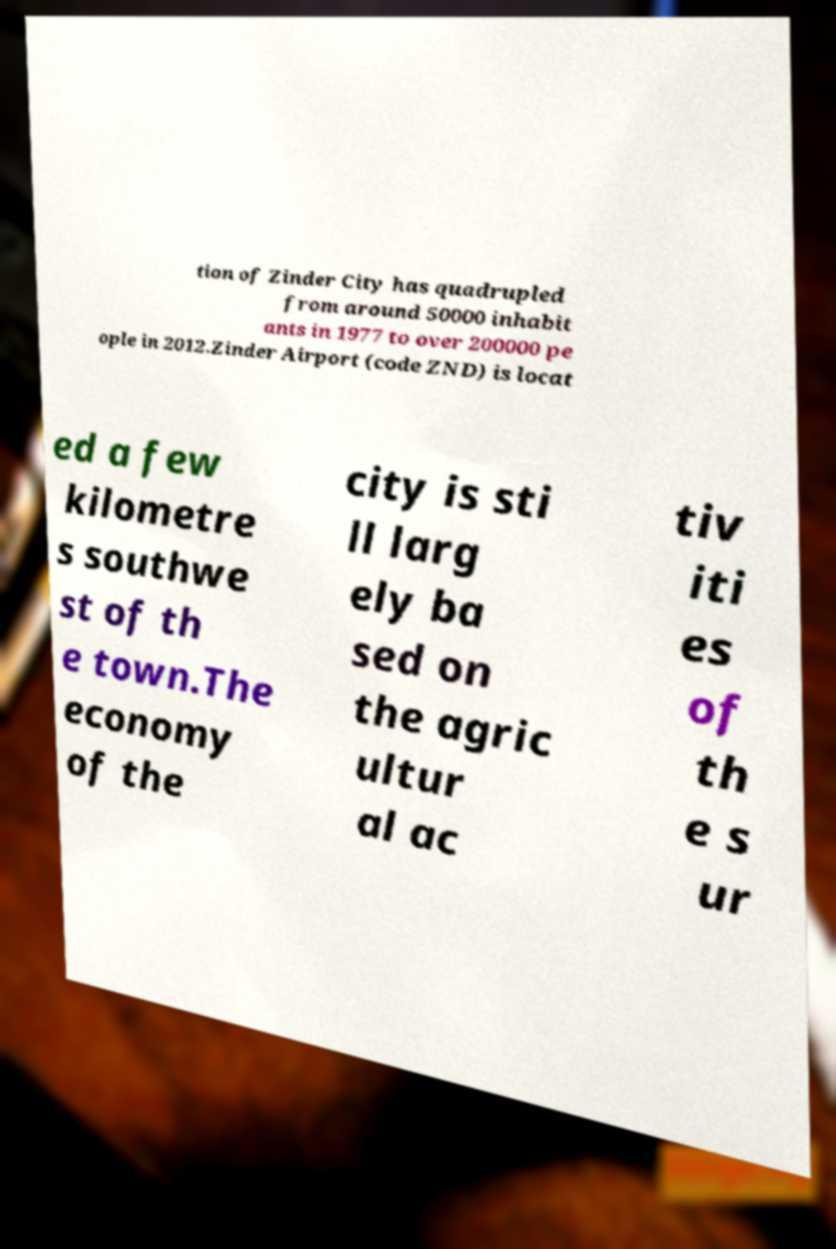I need the written content from this picture converted into text. Can you do that? tion of Zinder City has quadrupled from around 50000 inhabit ants in 1977 to over 200000 pe ople in 2012.Zinder Airport (code ZND) is locat ed a few kilometre s southwe st of th e town.The economy of the city is sti ll larg ely ba sed on the agric ultur al ac tiv iti es of th e s ur 